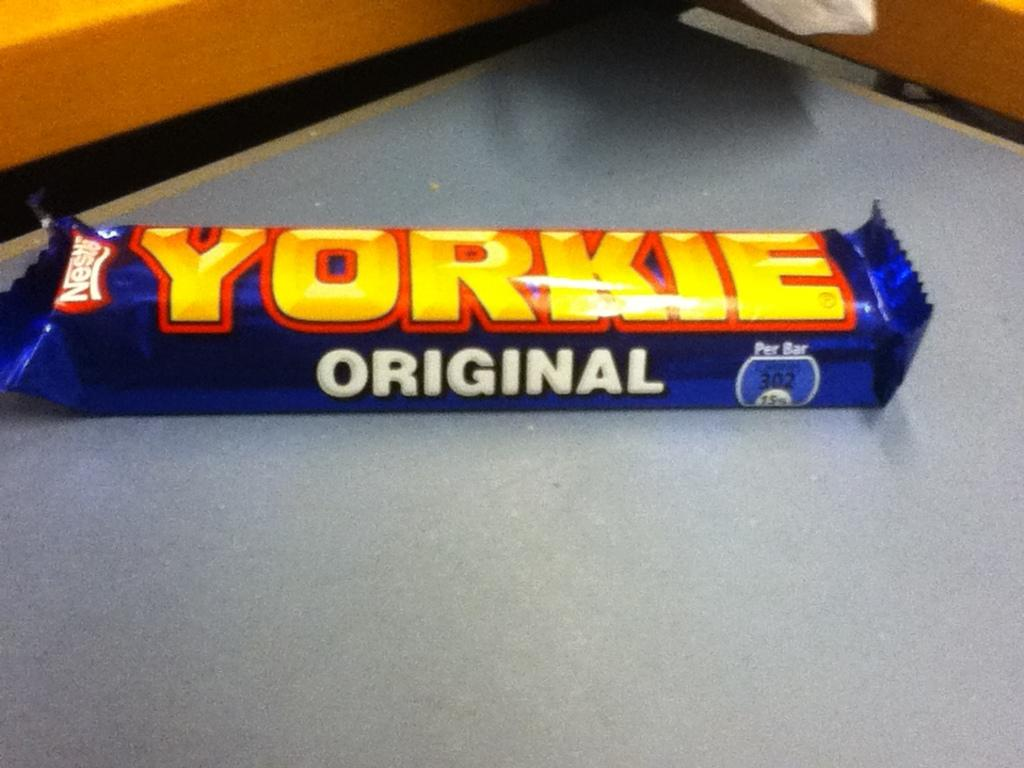<image>
Share a concise interpretation of the image provided. A Yorkie Original candy bar sits on a gray table. 